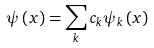Convert formula to latex. <formula><loc_0><loc_0><loc_500><loc_500>\psi \left ( x \right ) = \sum _ { k } c _ { k } \psi _ { k } \left ( x \right )</formula> 